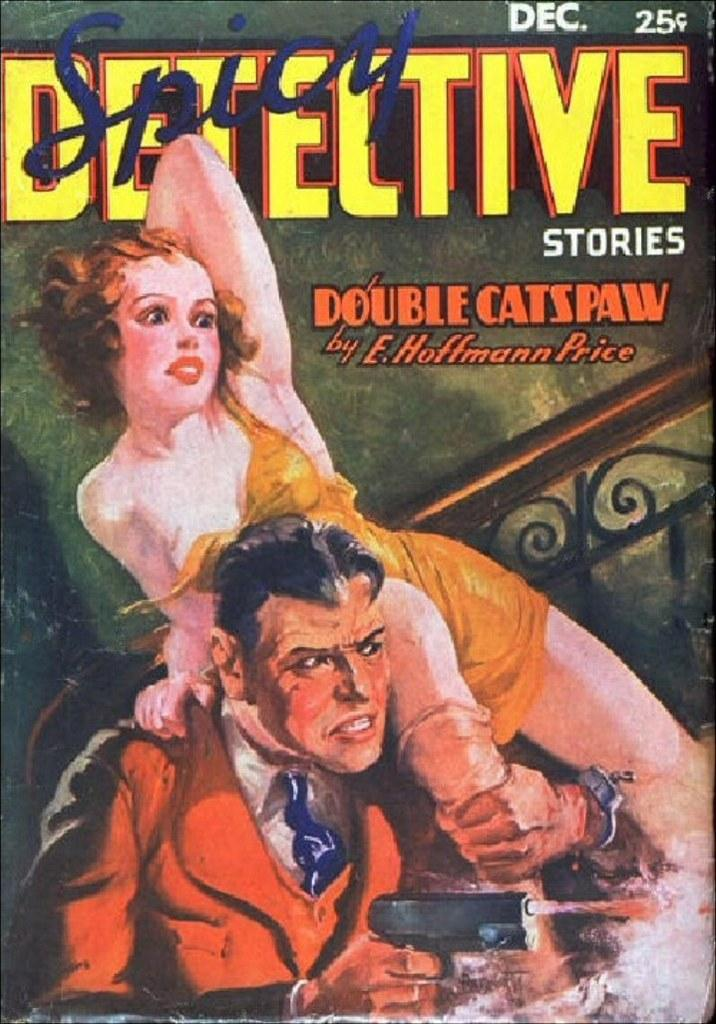<image>
Summarize the visual content of the image. A comic book titled Spicy Detective stories by E. Huffmann Price. 